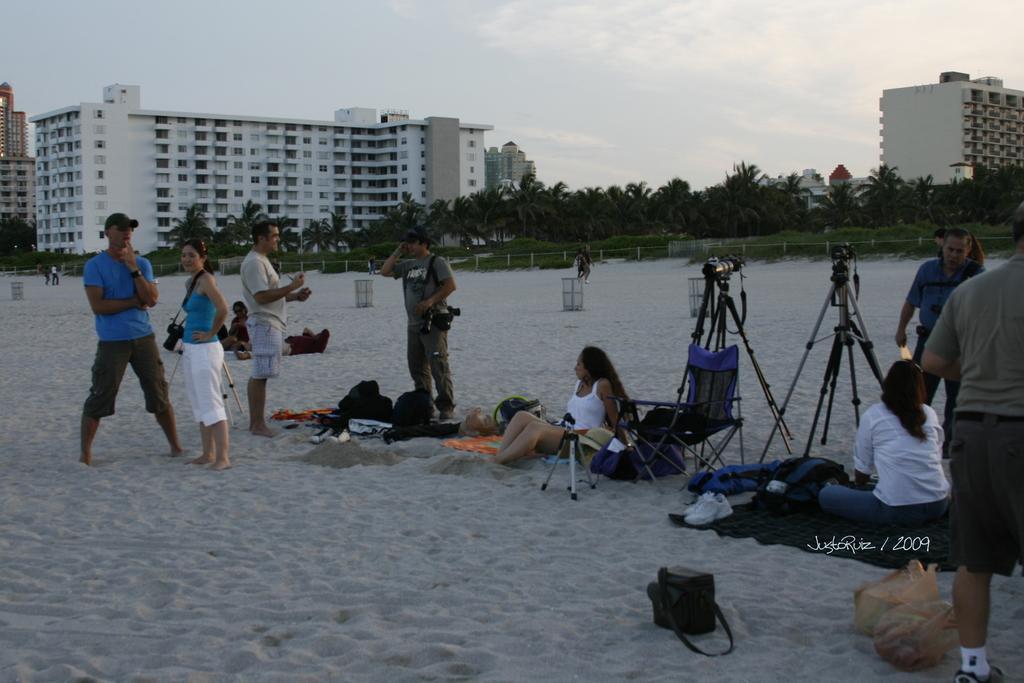In one or two sentences, can you explain what this image depicts? In this image we can see a few people on the sand, there are some cameras, stands, bags, shoes, bins, also we can see the sky, trees, buildings, and a fencing. 